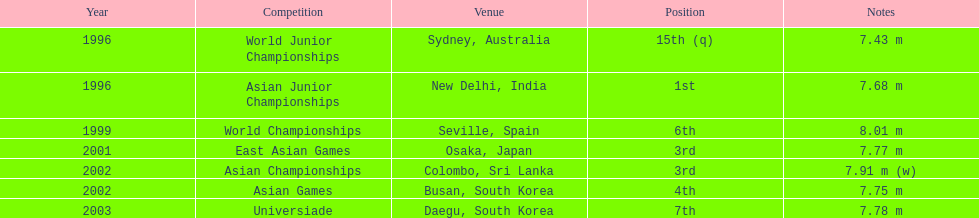What is the number of competitions that have been competed in? 7. I'm looking to parse the entire table for insights. Could you assist me with that? {'header': ['Year', 'Competition', 'Venue', 'Position', 'Notes'], 'rows': [['1996', 'World Junior Championships', 'Sydney, Australia', '15th (q)', '7.43 m'], ['1996', 'Asian Junior Championships', 'New Delhi, India', '1st', '7.68 m'], ['1999', 'World Championships', 'Seville, Spain', '6th', '8.01 m'], ['2001', 'East Asian Games', 'Osaka, Japan', '3rd', '7.77 m'], ['2002', 'Asian Championships', 'Colombo, Sri Lanka', '3rd', '7.91 m (w)'], ['2002', 'Asian Games', 'Busan, South Korea', '4th', '7.75 m'], ['2003', 'Universiade', 'Daegu, South Korea', '7th', '7.78 m']]} 